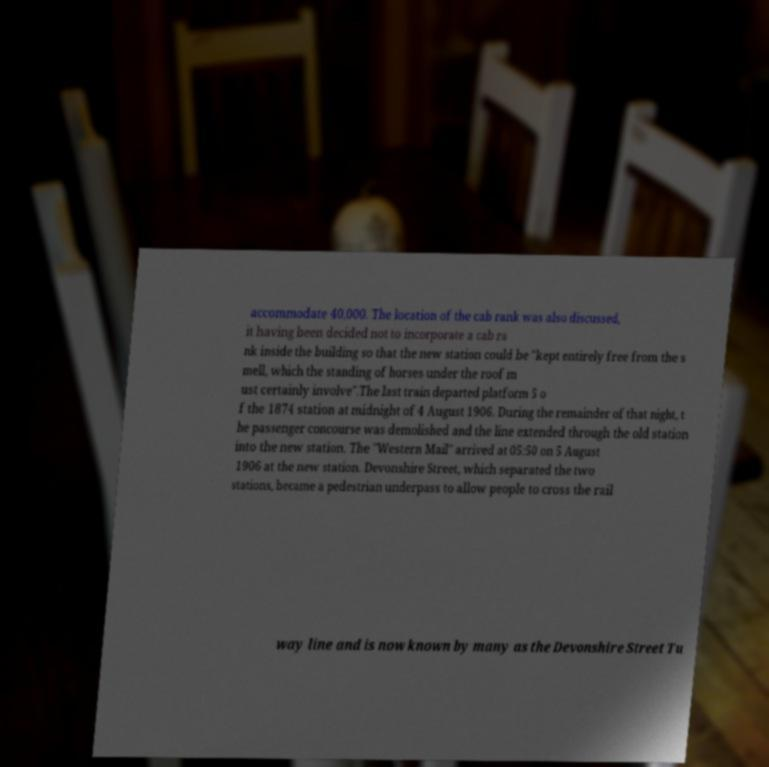I need the written content from this picture converted into text. Can you do that? accommodate 40,000. The location of the cab rank was also discussed, it having been decided not to incorporate a cab ra nk inside the building so that the new station could be "kept entirely free from the s mell, which the standing of horses under the roof m ust certainly involve".The last train departed platform 5 o f the 1874 station at midnight of 4 August 1906. During the remainder of that night, t he passenger concourse was demolished and the line extended through the old station into the new station. The "Western Mail" arrived at 05:50 on 5 August 1906 at the new station. Devonshire Street, which separated the two stations, became a pedestrian underpass to allow people to cross the rail way line and is now known by many as the Devonshire Street Tu 